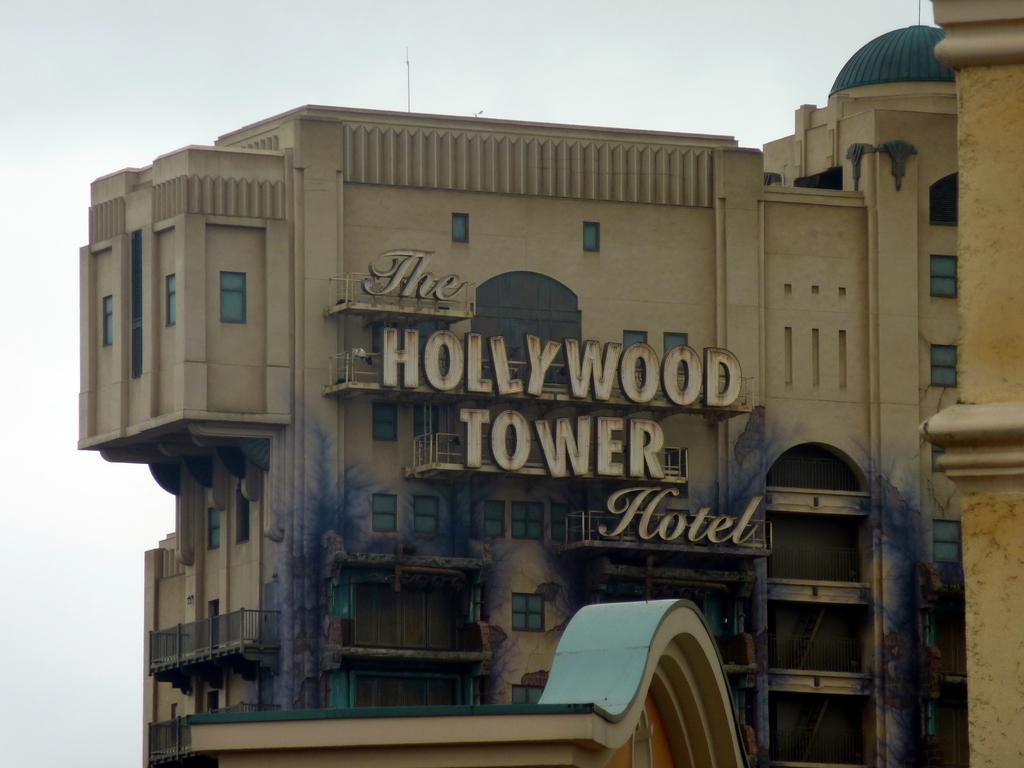What is the name of this hotel?
Provide a succinct answer. The hollywood tower hotel. 